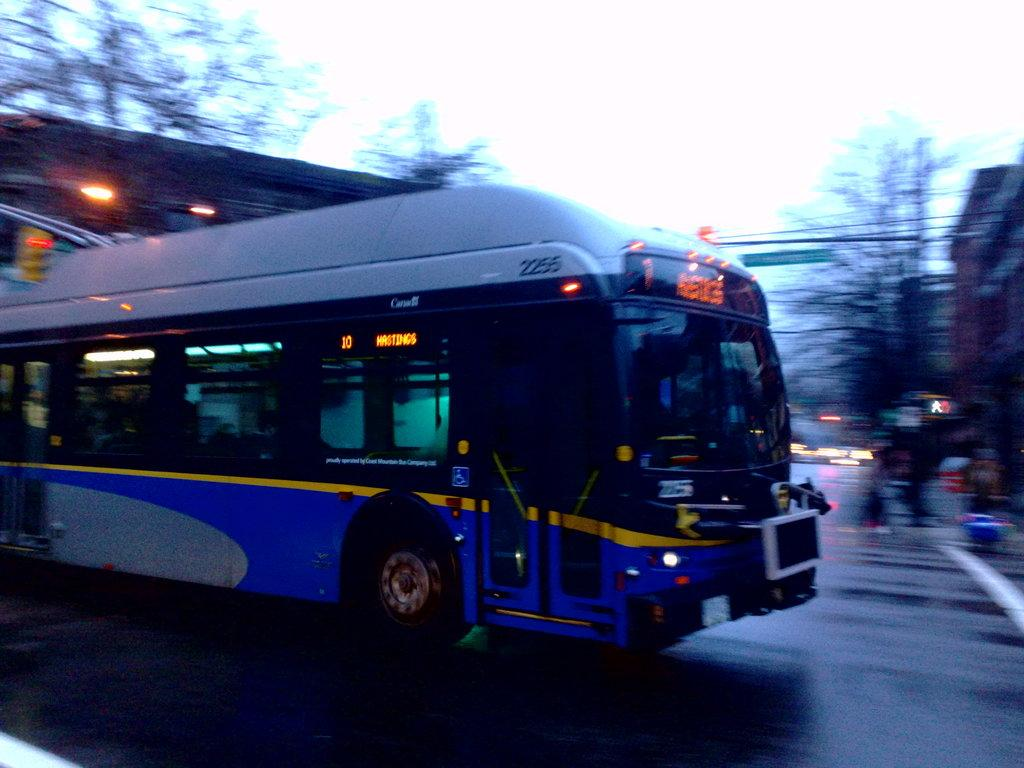What type of vehicle is in the image? There is a blue and white color bus in the image. What is the bus doing in the image? The bus is moving on the road. What can be seen in the background of the image? There is a blurred background in the image, and trees are visible in the background. What type of can is being used to create the bus in the image? There is no can present in the image, and the bus is not being created; it is a real vehicle moving on the road. 